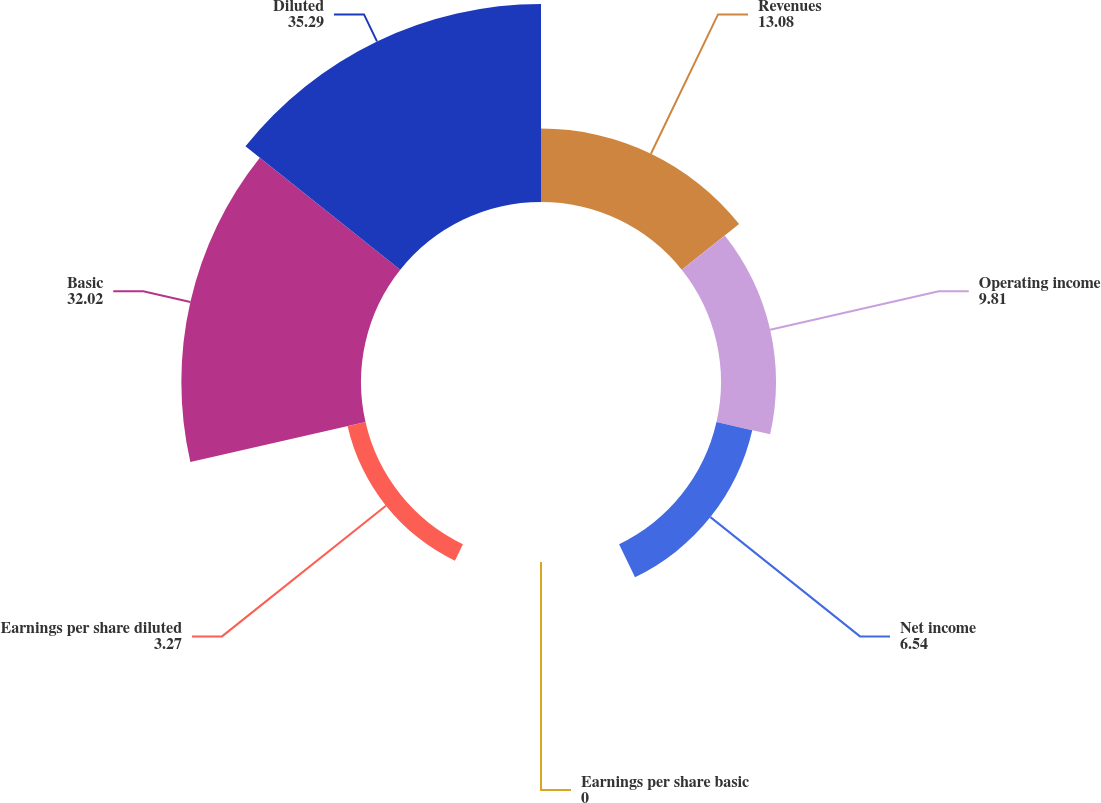<chart> <loc_0><loc_0><loc_500><loc_500><pie_chart><fcel>Revenues<fcel>Operating income<fcel>Net income<fcel>Earnings per share basic<fcel>Earnings per share diluted<fcel>Basic<fcel>Diluted<nl><fcel>13.08%<fcel>9.81%<fcel>6.54%<fcel>0.0%<fcel>3.27%<fcel>32.02%<fcel>35.29%<nl></chart> 